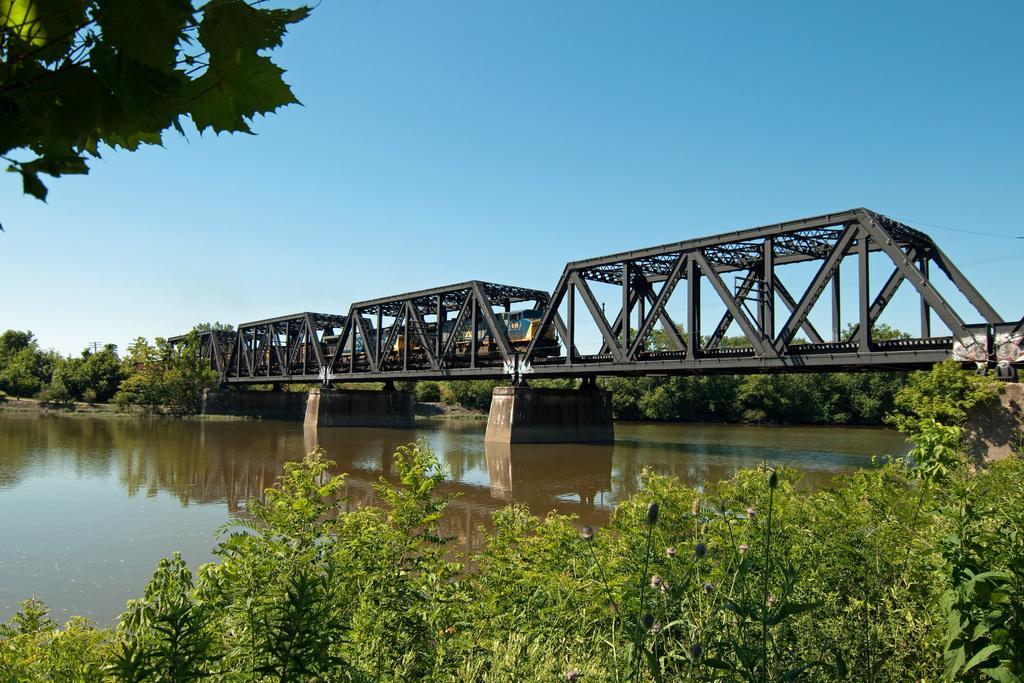Describe this image in one or two sentences. In this picture I can see at the bottom there are trees. In the middle water is flowing and there is a bridge, a train is moving from it. At the top it is the sky. 